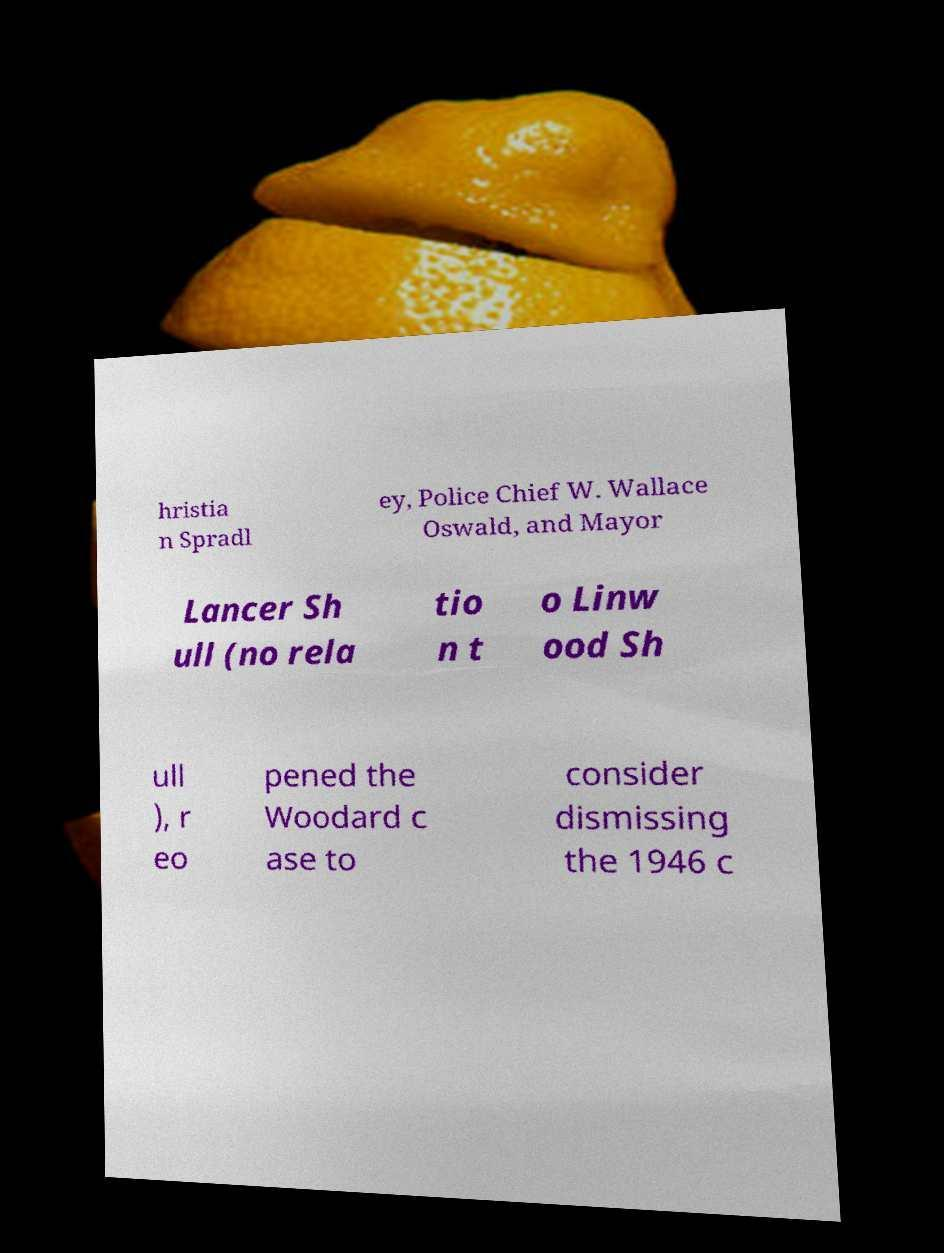I need the written content from this picture converted into text. Can you do that? hristia n Spradl ey, Police Chief W. Wallace Oswald, and Mayor Lancer Sh ull (no rela tio n t o Linw ood Sh ull ), r eo pened the Woodard c ase to consider dismissing the 1946 c 